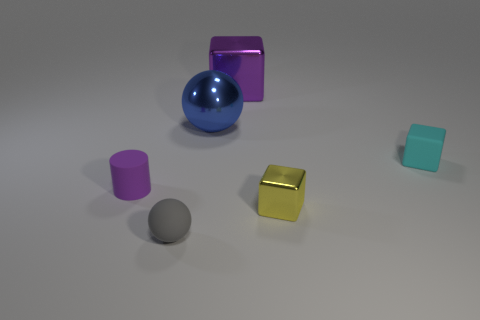Is the number of tiny balls that are behind the large metallic block less than the number of objects that are in front of the tiny rubber cylinder? After carefully examining the image, it appears that the number of tiny balls behind the large metallic block, which is one, is indeed less than the number of objects in front of the tiny rubber cylinder, which includes several objects of various sizes and colors. 